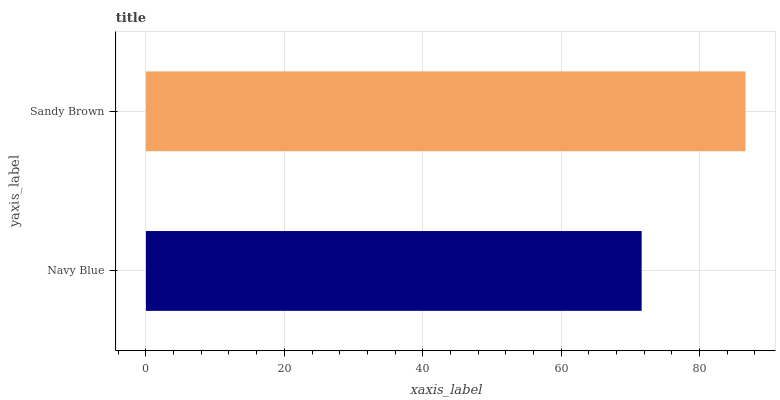Is Navy Blue the minimum?
Answer yes or no. Yes. Is Sandy Brown the maximum?
Answer yes or no. Yes. Is Sandy Brown the minimum?
Answer yes or no. No. Is Sandy Brown greater than Navy Blue?
Answer yes or no. Yes. Is Navy Blue less than Sandy Brown?
Answer yes or no. Yes. Is Navy Blue greater than Sandy Brown?
Answer yes or no. No. Is Sandy Brown less than Navy Blue?
Answer yes or no. No. Is Sandy Brown the high median?
Answer yes or no. Yes. Is Navy Blue the low median?
Answer yes or no. Yes. Is Navy Blue the high median?
Answer yes or no. No. Is Sandy Brown the low median?
Answer yes or no. No. 